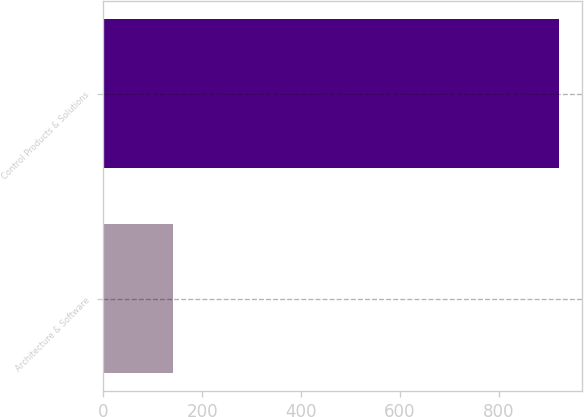Convert chart to OTSL. <chart><loc_0><loc_0><loc_500><loc_500><bar_chart><fcel>Architecture & Software<fcel>Control Products & Solutions<nl><fcel>140.6<fcel>921<nl></chart> 